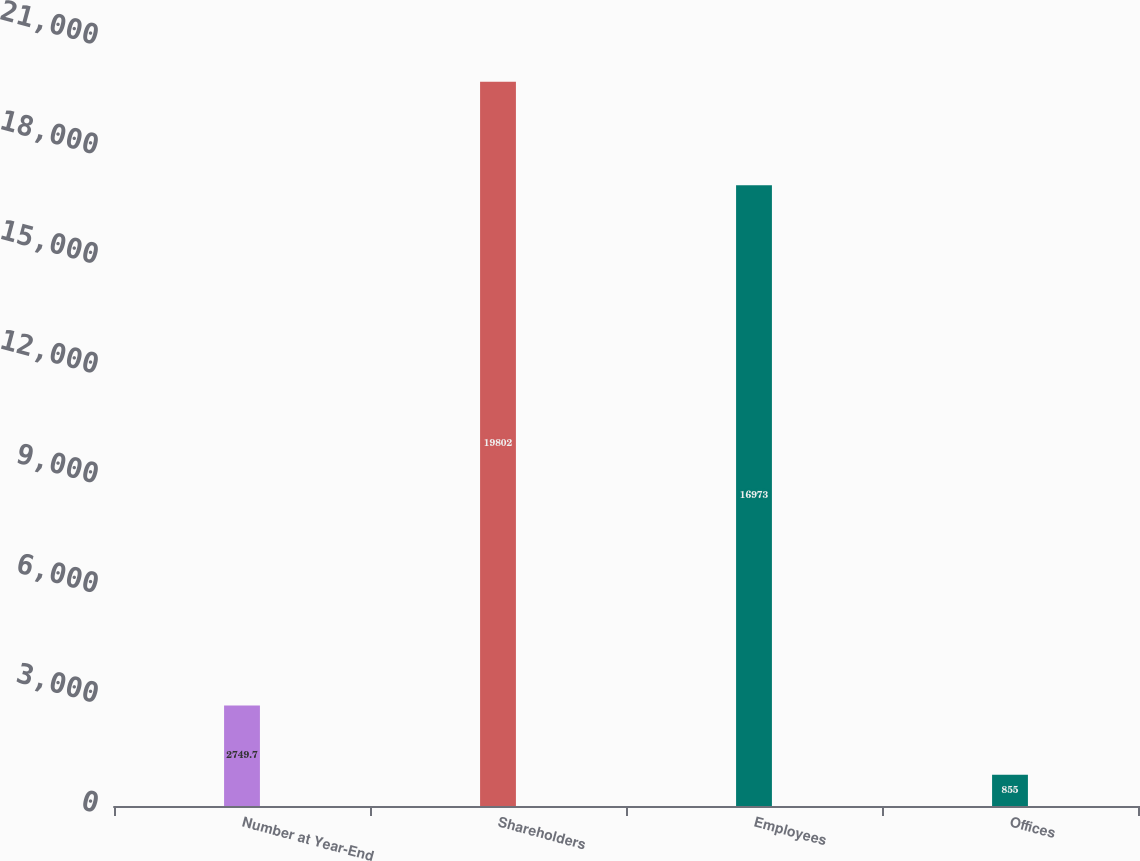<chart> <loc_0><loc_0><loc_500><loc_500><bar_chart><fcel>Number at Year-End<fcel>Shareholders<fcel>Employees<fcel>Offices<nl><fcel>2749.7<fcel>19802<fcel>16973<fcel>855<nl></chart> 